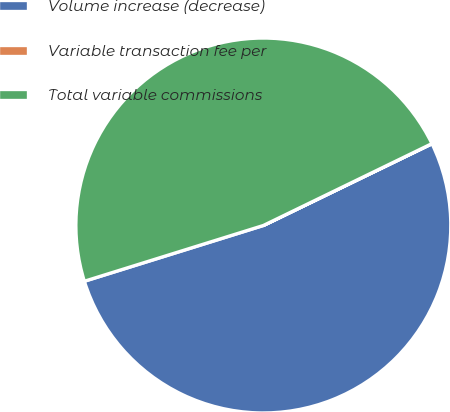Convert chart. <chart><loc_0><loc_0><loc_500><loc_500><pie_chart><fcel>Volume increase (decrease)<fcel>Variable transaction fee per<fcel>Total variable commissions<nl><fcel>52.38%<fcel>0.01%<fcel>47.61%<nl></chart> 